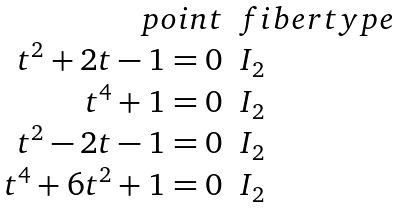<formula> <loc_0><loc_0><loc_500><loc_500>\begin{array} { r l } p o i n t & f i b e r t y p e \\ t ^ { 2 } + 2 t - 1 = 0 & I _ { 2 } \\ t ^ { 4 } + 1 = 0 & I _ { 2 } \\ t ^ { 2 } - 2 t - 1 = 0 & I _ { 2 } \\ t ^ { 4 } + 6 t ^ { 2 } + 1 = 0 & I _ { 2 } \end{array}</formula> 